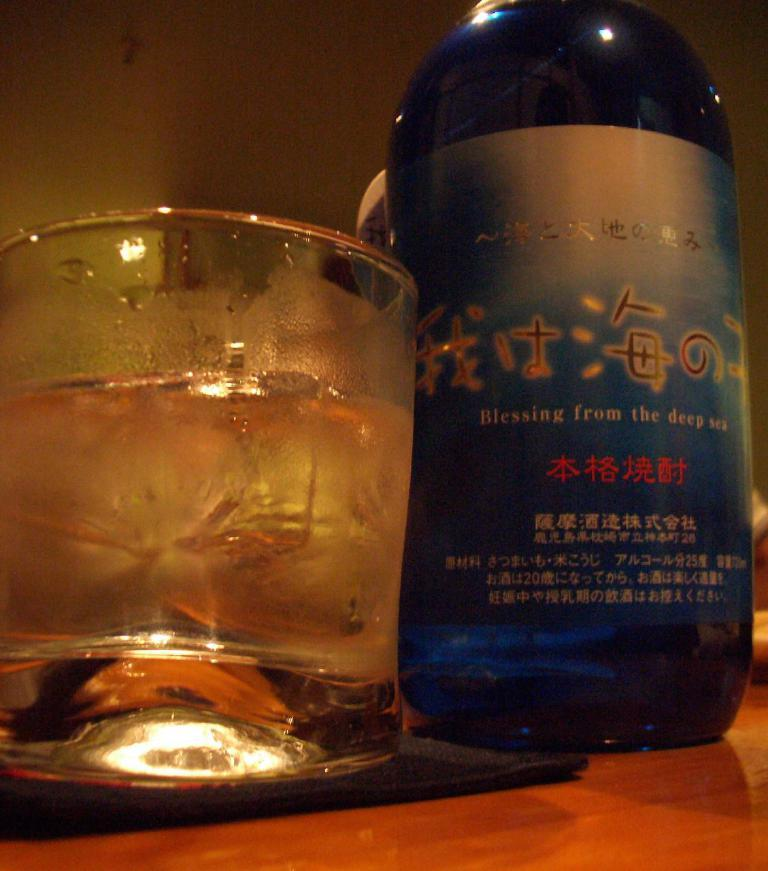<image>
Describe the image concisely. the word Blessing is on a bottle next to a glass 